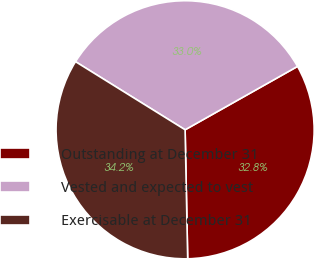Convert chart to OTSL. <chart><loc_0><loc_0><loc_500><loc_500><pie_chart><fcel>Outstanding at December 31<fcel>Vested and expected to vest<fcel>Exercisable at December 31<nl><fcel>32.85%<fcel>32.98%<fcel>34.17%<nl></chart> 